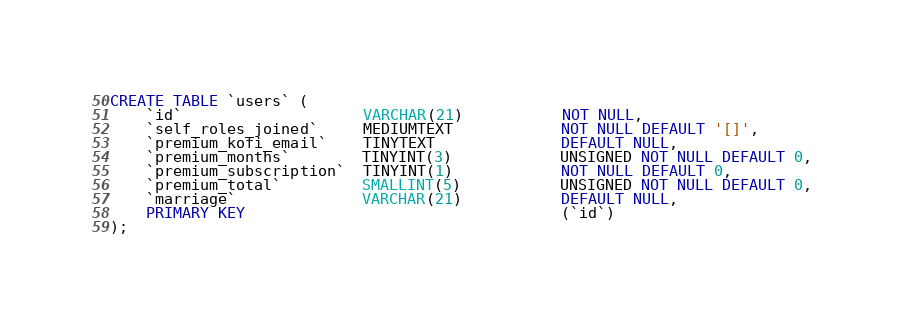<code> <loc_0><loc_0><loc_500><loc_500><_SQL_>CREATE TABLE `users` (
	`id`                    VARCHAR(21)           NOT NULL,
	`self_roles_joined`     MEDIUMTEXT            NOT NULL DEFAULT '[]',
	`premium_kofi_email`    TINYTEXT              DEFAULT NULL,
	`premium_months`        TINYINT(3)            UNSIGNED NOT NULL DEFAULT 0,
	`premium_subscription`  TINYINT(1)            NOT NULL DEFAULT 0,
	`premium_total`         SMALLINT(5)           UNSIGNED NOT NULL DEFAULT 0,
	`marriage`              VARCHAR(21)           DEFAULT NULL,
	PRIMARY KEY                                   (`id`)
);
</code> 